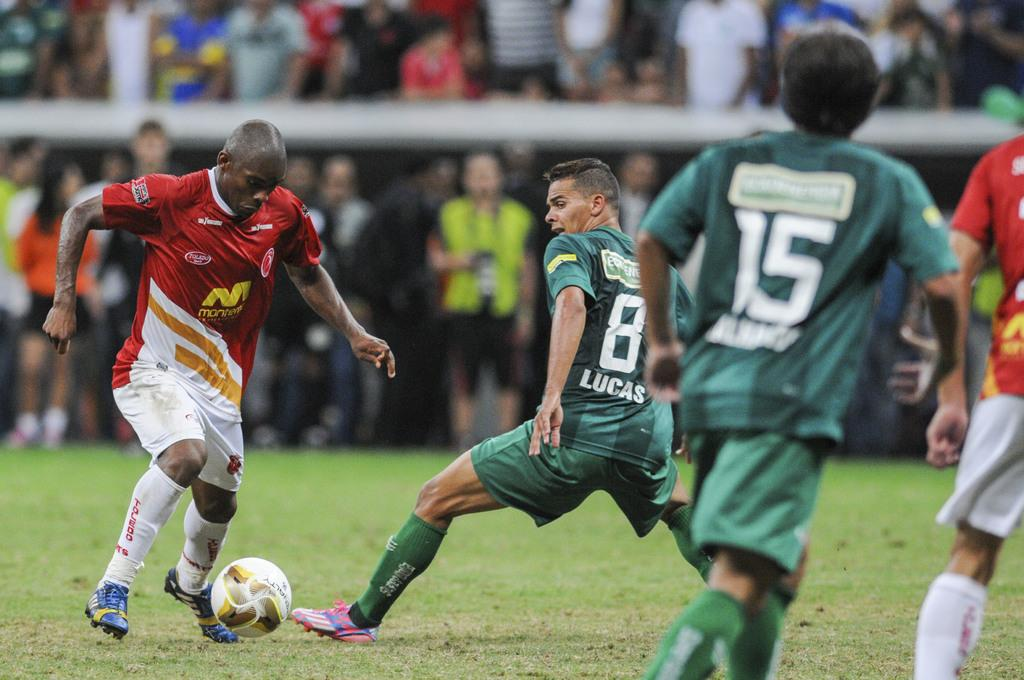What are the people in the image doing? The people in the image are players, and they are playing on the ground. What are the players wearing? The players are wearing clothes, socks, and shoes. What object is being used in the game? There is a ball in the image. What type of surface are the players playing on? There is grass visible in the image, so they are playing on grass. How is the background of the image depicted? The background of the image is blurred. What type of oatmeal can be seen in the image? There is no oatmeal present in the image. 